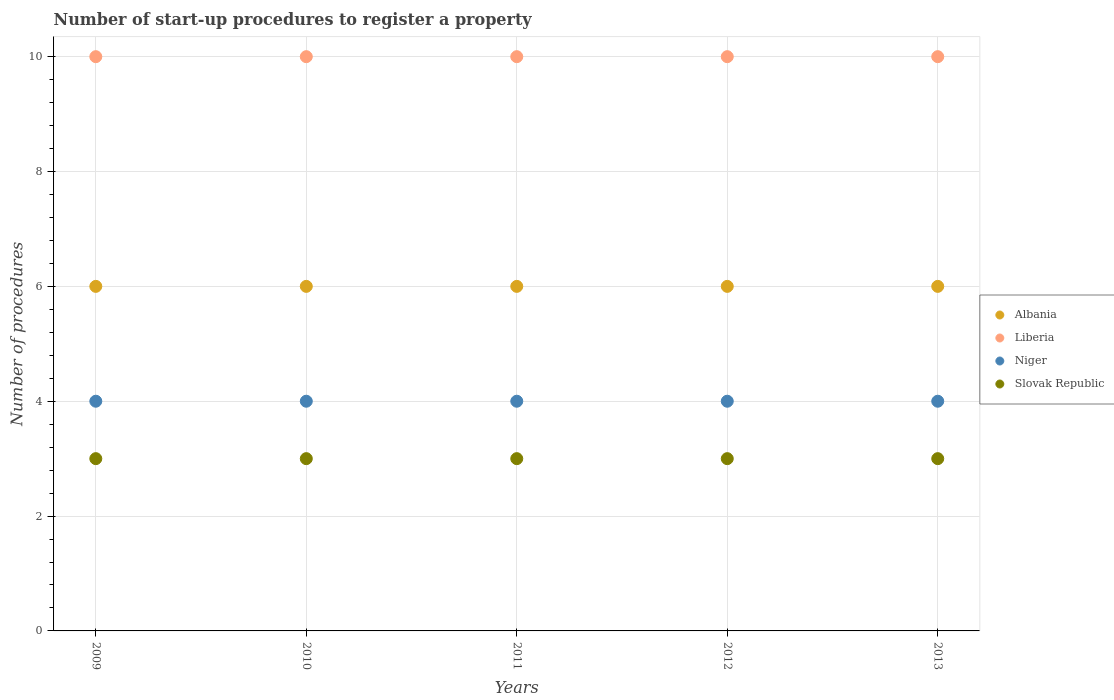How many different coloured dotlines are there?
Make the answer very short. 4. Is the number of dotlines equal to the number of legend labels?
Provide a succinct answer. Yes. What is the number of procedures required to register a property in Niger in 2012?
Provide a short and direct response. 4. Across all years, what is the maximum number of procedures required to register a property in Slovak Republic?
Ensure brevity in your answer.  3. In which year was the number of procedures required to register a property in Niger minimum?
Provide a succinct answer. 2009. What is the total number of procedures required to register a property in Slovak Republic in the graph?
Keep it short and to the point. 15. What is the difference between the number of procedures required to register a property in Liberia in 2010 and that in 2012?
Your answer should be compact. 0. What is the difference between the number of procedures required to register a property in Liberia in 2010 and the number of procedures required to register a property in Slovak Republic in 2009?
Provide a succinct answer. 7. Is the number of procedures required to register a property in Niger in 2010 less than that in 2013?
Your answer should be compact. No. Is the difference between the number of procedures required to register a property in Albania in 2010 and 2012 greater than the difference between the number of procedures required to register a property in Liberia in 2010 and 2012?
Your answer should be very brief. No. What is the difference between the highest and the lowest number of procedures required to register a property in Niger?
Offer a terse response. 0. In how many years, is the number of procedures required to register a property in Liberia greater than the average number of procedures required to register a property in Liberia taken over all years?
Your response must be concise. 0. Is it the case that in every year, the sum of the number of procedures required to register a property in Albania and number of procedures required to register a property in Slovak Republic  is greater than the sum of number of procedures required to register a property in Niger and number of procedures required to register a property in Liberia?
Offer a terse response. No. Is it the case that in every year, the sum of the number of procedures required to register a property in Niger and number of procedures required to register a property in Albania  is greater than the number of procedures required to register a property in Slovak Republic?
Give a very brief answer. Yes. Does the number of procedures required to register a property in Liberia monotonically increase over the years?
Your answer should be compact. No. Is the number of procedures required to register a property in Niger strictly less than the number of procedures required to register a property in Slovak Republic over the years?
Offer a terse response. No. What is the difference between two consecutive major ticks on the Y-axis?
Keep it short and to the point. 2. Are the values on the major ticks of Y-axis written in scientific E-notation?
Ensure brevity in your answer.  No. Does the graph contain any zero values?
Keep it short and to the point. No. Does the graph contain grids?
Ensure brevity in your answer.  Yes. Where does the legend appear in the graph?
Make the answer very short. Center right. How are the legend labels stacked?
Provide a succinct answer. Vertical. What is the title of the graph?
Your answer should be compact. Number of start-up procedures to register a property. What is the label or title of the X-axis?
Your response must be concise. Years. What is the label or title of the Y-axis?
Provide a short and direct response. Number of procedures. What is the Number of procedures in Albania in 2009?
Make the answer very short. 6. What is the Number of procedures of Liberia in 2009?
Offer a terse response. 10. What is the Number of procedures in Niger in 2009?
Offer a very short reply. 4. What is the Number of procedures of Slovak Republic in 2009?
Offer a terse response. 3. What is the Number of procedures of Albania in 2010?
Keep it short and to the point. 6. What is the Number of procedures in Albania in 2011?
Offer a very short reply. 6. What is the Number of procedures in Liberia in 2011?
Ensure brevity in your answer.  10. What is the Number of procedures of Slovak Republic in 2011?
Make the answer very short. 3. What is the Number of procedures in Niger in 2012?
Keep it short and to the point. 4. What is the Number of procedures of Albania in 2013?
Provide a short and direct response. 6. What is the Number of procedures of Liberia in 2013?
Offer a terse response. 10. Across all years, what is the maximum Number of procedures of Albania?
Offer a terse response. 6. Across all years, what is the maximum Number of procedures in Liberia?
Give a very brief answer. 10. Across all years, what is the maximum Number of procedures in Slovak Republic?
Give a very brief answer. 3. Across all years, what is the minimum Number of procedures of Albania?
Give a very brief answer. 6. Across all years, what is the minimum Number of procedures in Liberia?
Provide a short and direct response. 10. Across all years, what is the minimum Number of procedures of Slovak Republic?
Your response must be concise. 3. What is the total Number of procedures in Niger in the graph?
Provide a short and direct response. 20. What is the difference between the Number of procedures in Albania in 2009 and that in 2010?
Ensure brevity in your answer.  0. What is the difference between the Number of procedures of Liberia in 2009 and that in 2010?
Provide a succinct answer. 0. What is the difference between the Number of procedures of Niger in 2009 and that in 2011?
Your response must be concise. 0. What is the difference between the Number of procedures in Slovak Republic in 2009 and that in 2011?
Provide a short and direct response. 0. What is the difference between the Number of procedures of Niger in 2009 and that in 2012?
Offer a very short reply. 0. What is the difference between the Number of procedures of Slovak Republic in 2009 and that in 2012?
Your answer should be very brief. 0. What is the difference between the Number of procedures of Albania in 2009 and that in 2013?
Provide a short and direct response. 0. What is the difference between the Number of procedures of Niger in 2009 and that in 2013?
Offer a very short reply. 0. What is the difference between the Number of procedures in Albania in 2010 and that in 2011?
Your answer should be very brief. 0. What is the difference between the Number of procedures of Slovak Republic in 2010 and that in 2011?
Give a very brief answer. 0. What is the difference between the Number of procedures of Albania in 2010 and that in 2012?
Keep it short and to the point. 0. What is the difference between the Number of procedures in Niger in 2010 and that in 2012?
Your answer should be compact. 0. What is the difference between the Number of procedures in Liberia in 2010 and that in 2013?
Keep it short and to the point. 0. What is the difference between the Number of procedures in Niger in 2010 and that in 2013?
Provide a succinct answer. 0. What is the difference between the Number of procedures in Liberia in 2011 and that in 2012?
Provide a succinct answer. 0. What is the difference between the Number of procedures of Slovak Republic in 2011 and that in 2012?
Give a very brief answer. 0. What is the difference between the Number of procedures of Albania in 2011 and that in 2013?
Offer a terse response. 0. What is the difference between the Number of procedures of Liberia in 2011 and that in 2013?
Provide a succinct answer. 0. What is the difference between the Number of procedures of Albania in 2009 and the Number of procedures of Liberia in 2011?
Keep it short and to the point. -4. What is the difference between the Number of procedures of Liberia in 2009 and the Number of procedures of Niger in 2011?
Give a very brief answer. 6. What is the difference between the Number of procedures of Albania in 2009 and the Number of procedures of Liberia in 2012?
Your answer should be compact. -4. What is the difference between the Number of procedures of Albania in 2009 and the Number of procedures of Niger in 2012?
Your response must be concise. 2. What is the difference between the Number of procedures in Albania in 2009 and the Number of procedures in Slovak Republic in 2012?
Provide a succinct answer. 3. What is the difference between the Number of procedures of Liberia in 2009 and the Number of procedures of Slovak Republic in 2012?
Make the answer very short. 7. What is the difference between the Number of procedures in Liberia in 2009 and the Number of procedures in Niger in 2013?
Your answer should be very brief. 6. What is the difference between the Number of procedures in Niger in 2009 and the Number of procedures in Slovak Republic in 2013?
Provide a succinct answer. 1. What is the difference between the Number of procedures of Liberia in 2010 and the Number of procedures of Niger in 2011?
Your answer should be very brief. 6. What is the difference between the Number of procedures in Niger in 2010 and the Number of procedures in Slovak Republic in 2011?
Your answer should be very brief. 1. What is the difference between the Number of procedures in Albania in 2010 and the Number of procedures in Niger in 2012?
Ensure brevity in your answer.  2. What is the difference between the Number of procedures in Albania in 2010 and the Number of procedures in Slovak Republic in 2012?
Keep it short and to the point. 3. What is the difference between the Number of procedures in Liberia in 2010 and the Number of procedures in Niger in 2012?
Your answer should be very brief. 6. What is the difference between the Number of procedures of Albania in 2010 and the Number of procedures of Liberia in 2013?
Give a very brief answer. -4. What is the difference between the Number of procedures of Albania in 2010 and the Number of procedures of Niger in 2013?
Keep it short and to the point. 2. What is the difference between the Number of procedures in Albania in 2011 and the Number of procedures in Slovak Republic in 2012?
Offer a terse response. 3. What is the difference between the Number of procedures of Liberia in 2011 and the Number of procedures of Niger in 2012?
Your answer should be compact. 6. What is the difference between the Number of procedures of Liberia in 2011 and the Number of procedures of Slovak Republic in 2012?
Your answer should be very brief. 7. What is the difference between the Number of procedures in Liberia in 2011 and the Number of procedures in Niger in 2013?
Give a very brief answer. 6. What is the difference between the Number of procedures in Liberia in 2011 and the Number of procedures in Slovak Republic in 2013?
Keep it short and to the point. 7. What is the difference between the Number of procedures of Niger in 2011 and the Number of procedures of Slovak Republic in 2013?
Keep it short and to the point. 1. What is the difference between the Number of procedures in Albania in 2012 and the Number of procedures in Slovak Republic in 2013?
Give a very brief answer. 3. What is the difference between the Number of procedures in Liberia in 2012 and the Number of procedures in Niger in 2013?
Ensure brevity in your answer.  6. What is the difference between the Number of procedures in Liberia in 2012 and the Number of procedures in Slovak Republic in 2013?
Keep it short and to the point. 7. What is the average Number of procedures in Albania per year?
Your answer should be compact. 6. What is the average Number of procedures of Liberia per year?
Your response must be concise. 10. What is the average Number of procedures in Niger per year?
Provide a succinct answer. 4. What is the average Number of procedures of Slovak Republic per year?
Give a very brief answer. 3. In the year 2009, what is the difference between the Number of procedures in Liberia and Number of procedures in Slovak Republic?
Offer a terse response. 7. In the year 2009, what is the difference between the Number of procedures of Niger and Number of procedures of Slovak Republic?
Your answer should be very brief. 1. In the year 2010, what is the difference between the Number of procedures of Albania and Number of procedures of Liberia?
Your answer should be compact. -4. In the year 2010, what is the difference between the Number of procedures in Albania and Number of procedures in Niger?
Offer a very short reply. 2. In the year 2012, what is the difference between the Number of procedures of Albania and Number of procedures of Niger?
Provide a short and direct response. 2. In the year 2012, what is the difference between the Number of procedures in Albania and Number of procedures in Slovak Republic?
Offer a terse response. 3. In the year 2012, what is the difference between the Number of procedures in Niger and Number of procedures in Slovak Republic?
Offer a very short reply. 1. In the year 2013, what is the difference between the Number of procedures in Albania and Number of procedures in Liberia?
Give a very brief answer. -4. In the year 2013, what is the difference between the Number of procedures in Liberia and Number of procedures in Slovak Republic?
Your response must be concise. 7. In the year 2013, what is the difference between the Number of procedures of Niger and Number of procedures of Slovak Republic?
Offer a terse response. 1. What is the ratio of the Number of procedures of Slovak Republic in 2009 to that in 2010?
Keep it short and to the point. 1. What is the ratio of the Number of procedures in Albania in 2009 to that in 2011?
Give a very brief answer. 1. What is the ratio of the Number of procedures of Albania in 2009 to that in 2012?
Ensure brevity in your answer.  1. What is the ratio of the Number of procedures of Niger in 2009 to that in 2012?
Ensure brevity in your answer.  1. What is the ratio of the Number of procedures in Liberia in 2009 to that in 2013?
Make the answer very short. 1. What is the ratio of the Number of procedures of Albania in 2010 to that in 2011?
Your response must be concise. 1. What is the ratio of the Number of procedures of Slovak Republic in 2010 to that in 2011?
Offer a very short reply. 1. What is the ratio of the Number of procedures of Albania in 2010 to that in 2012?
Your answer should be very brief. 1. What is the ratio of the Number of procedures of Liberia in 2010 to that in 2012?
Your answer should be very brief. 1. What is the ratio of the Number of procedures in Niger in 2010 to that in 2012?
Provide a succinct answer. 1. What is the ratio of the Number of procedures in Albania in 2010 to that in 2013?
Your response must be concise. 1. What is the ratio of the Number of procedures of Slovak Republic in 2010 to that in 2013?
Make the answer very short. 1. What is the ratio of the Number of procedures in Albania in 2011 to that in 2012?
Your answer should be very brief. 1. What is the ratio of the Number of procedures of Liberia in 2011 to that in 2012?
Offer a terse response. 1. What is the ratio of the Number of procedures in Albania in 2011 to that in 2013?
Make the answer very short. 1. What is the ratio of the Number of procedures in Liberia in 2011 to that in 2013?
Offer a terse response. 1. What is the ratio of the Number of procedures in Niger in 2011 to that in 2013?
Offer a terse response. 1. What is the ratio of the Number of procedures in Liberia in 2012 to that in 2013?
Provide a short and direct response. 1. What is the difference between the highest and the second highest Number of procedures in Liberia?
Give a very brief answer. 0. What is the difference between the highest and the second highest Number of procedures in Slovak Republic?
Your answer should be compact. 0. 